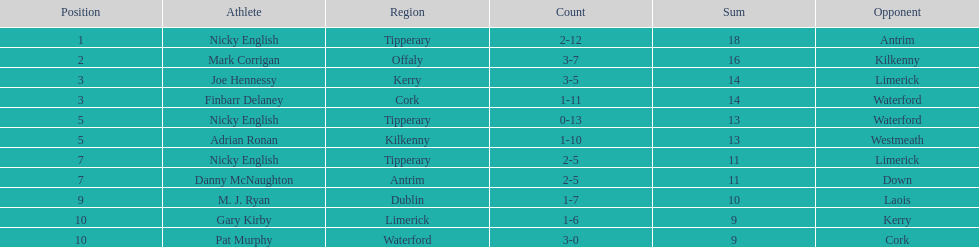What is the least total on the list? 9. 